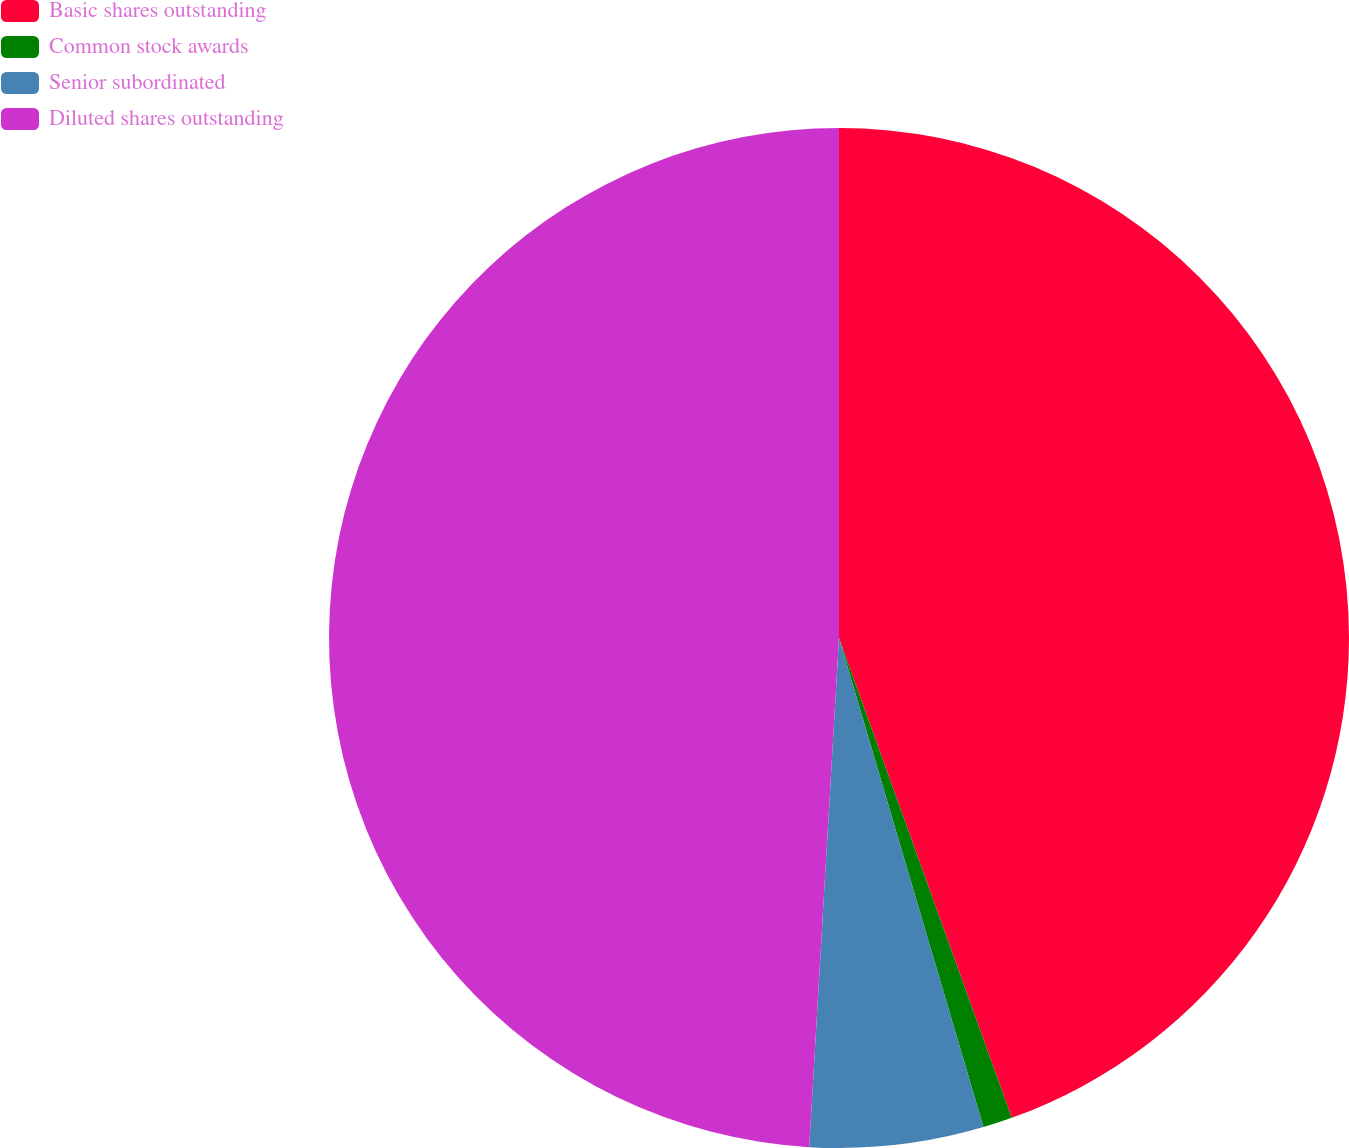<chart> <loc_0><loc_0><loc_500><loc_500><pie_chart><fcel>Basic shares outstanding<fcel>Common stock awards<fcel>Senior subordinated<fcel>Diluted shares outstanding<nl><fcel>44.5%<fcel>0.93%<fcel>5.5%<fcel>49.07%<nl></chart> 